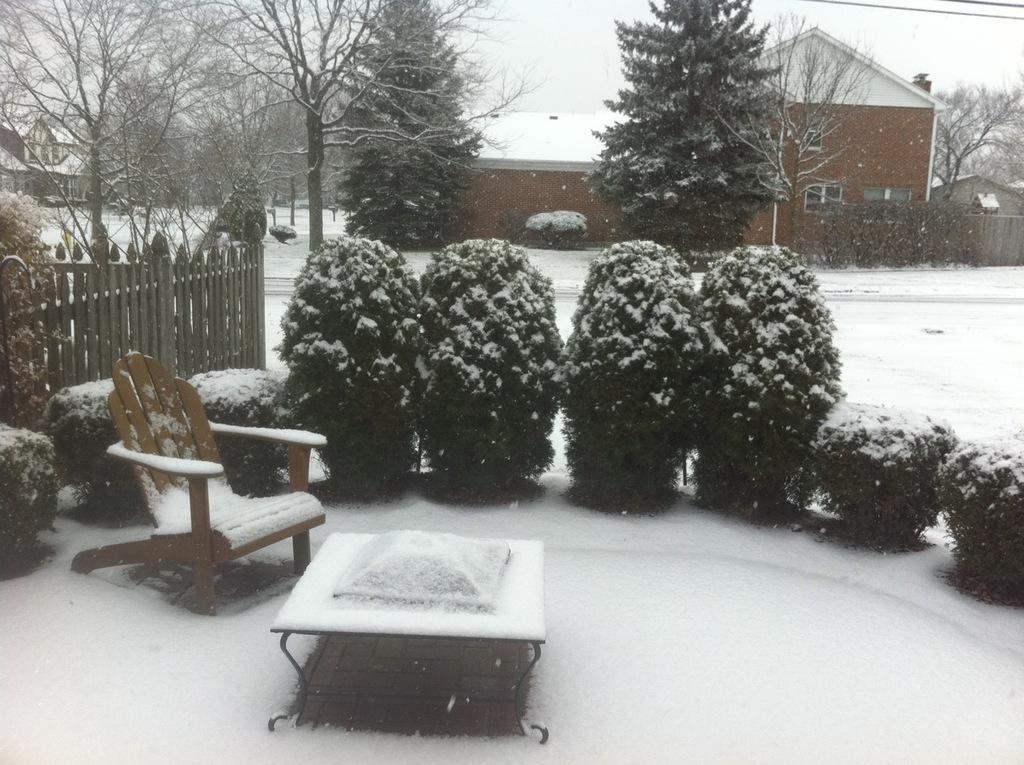Could you give a brief overview of what you see in this image? In the foreground of the picture, there is a table, a chair, few plants, wooden fencing and trees. We can also see snow on these objects. We can see few houses, trees and the sky in the background. 